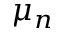Convert formula to latex. <formula><loc_0><loc_0><loc_500><loc_500>\mu _ { n }</formula> 